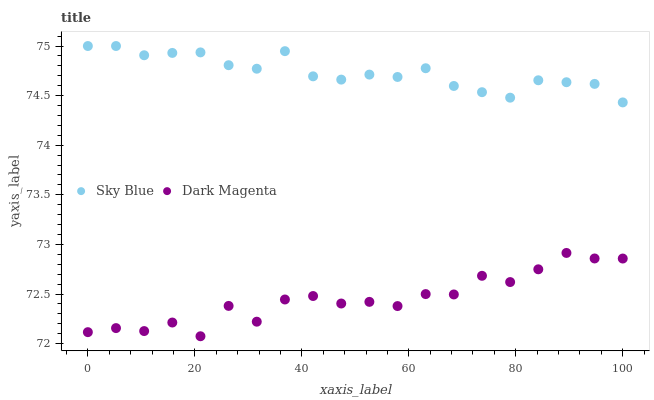Does Dark Magenta have the minimum area under the curve?
Answer yes or no. Yes. Does Sky Blue have the maximum area under the curve?
Answer yes or no. Yes. Does Dark Magenta have the maximum area under the curve?
Answer yes or no. No. Is Sky Blue the smoothest?
Answer yes or no. Yes. Is Dark Magenta the roughest?
Answer yes or no. Yes. Is Dark Magenta the smoothest?
Answer yes or no. No. Does Dark Magenta have the lowest value?
Answer yes or no. Yes. Does Sky Blue have the highest value?
Answer yes or no. Yes. Does Dark Magenta have the highest value?
Answer yes or no. No. Is Dark Magenta less than Sky Blue?
Answer yes or no. Yes. Is Sky Blue greater than Dark Magenta?
Answer yes or no. Yes. Does Dark Magenta intersect Sky Blue?
Answer yes or no. No. 